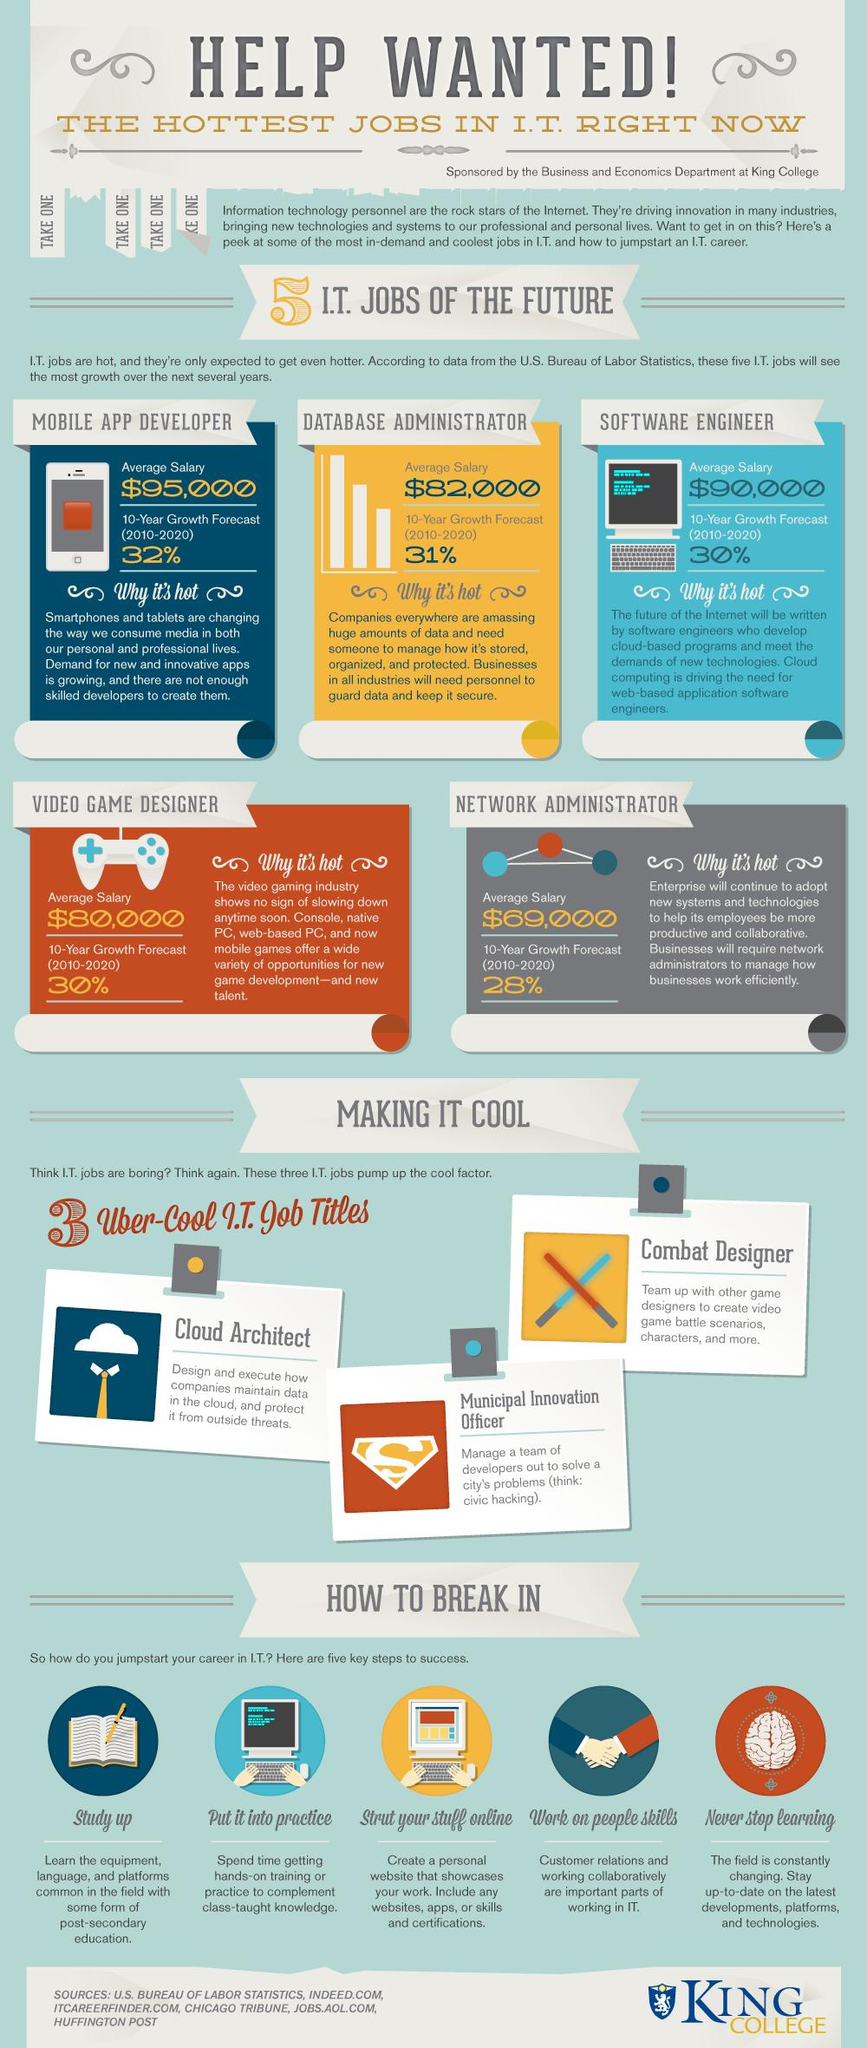Mention a couple of crucial points in this snapshot. The title of Cloud Architect involves the maintenance of data in a cloud computing environment. The IT job with an average salary less than $80,000 is Network Administrator. Based on predicted job growth rates, mobile app development is expected to have the highest 10-year growth rate among IT jobs. 